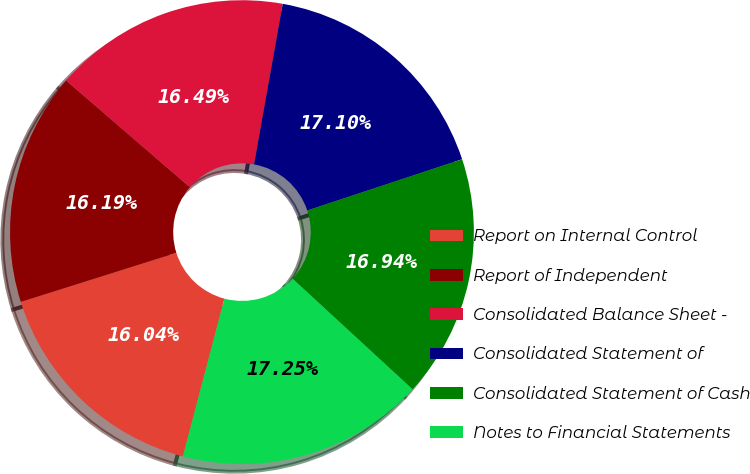Convert chart. <chart><loc_0><loc_0><loc_500><loc_500><pie_chart><fcel>Report on Internal Control<fcel>Report of Independent<fcel>Consolidated Balance Sheet -<fcel>Consolidated Statement of<fcel>Consolidated Statement of Cash<fcel>Notes to Financial Statements<nl><fcel>16.04%<fcel>16.19%<fcel>16.49%<fcel>17.1%<fcel>16.94%<fcel>17.25%<nl></chart> 